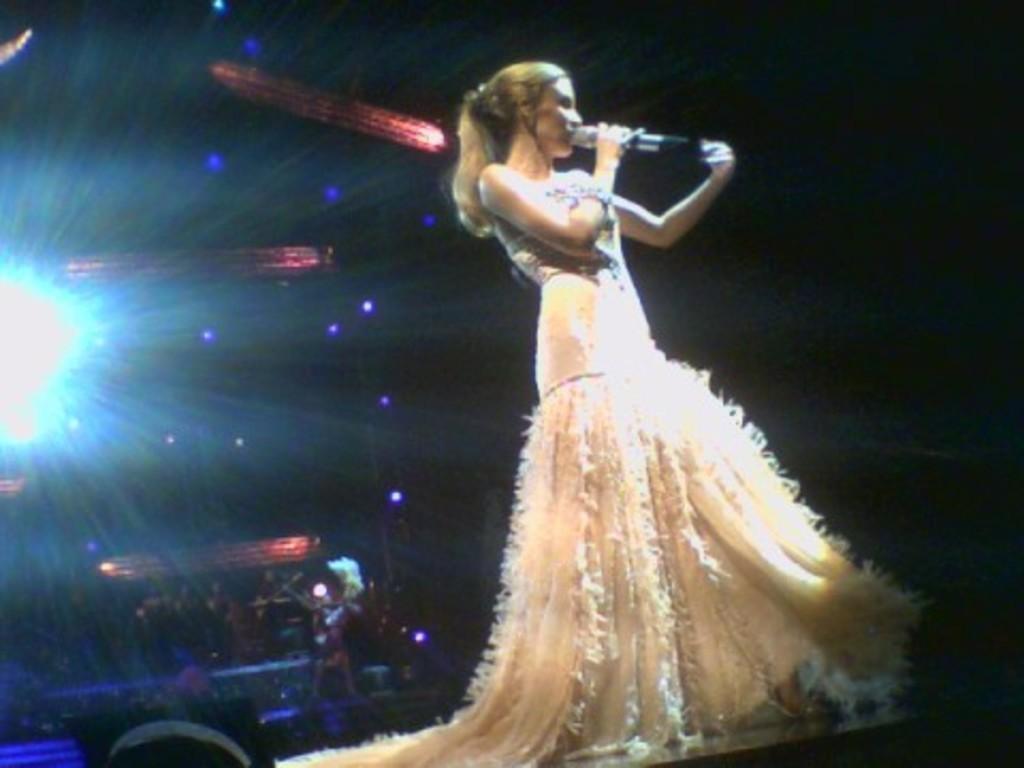Describe this image in one or two sentences. In the image we can see a woman standing, wearing clothes, bracelet and she is holding a microphone in her hand. Here we can see the light and the background is dark. 